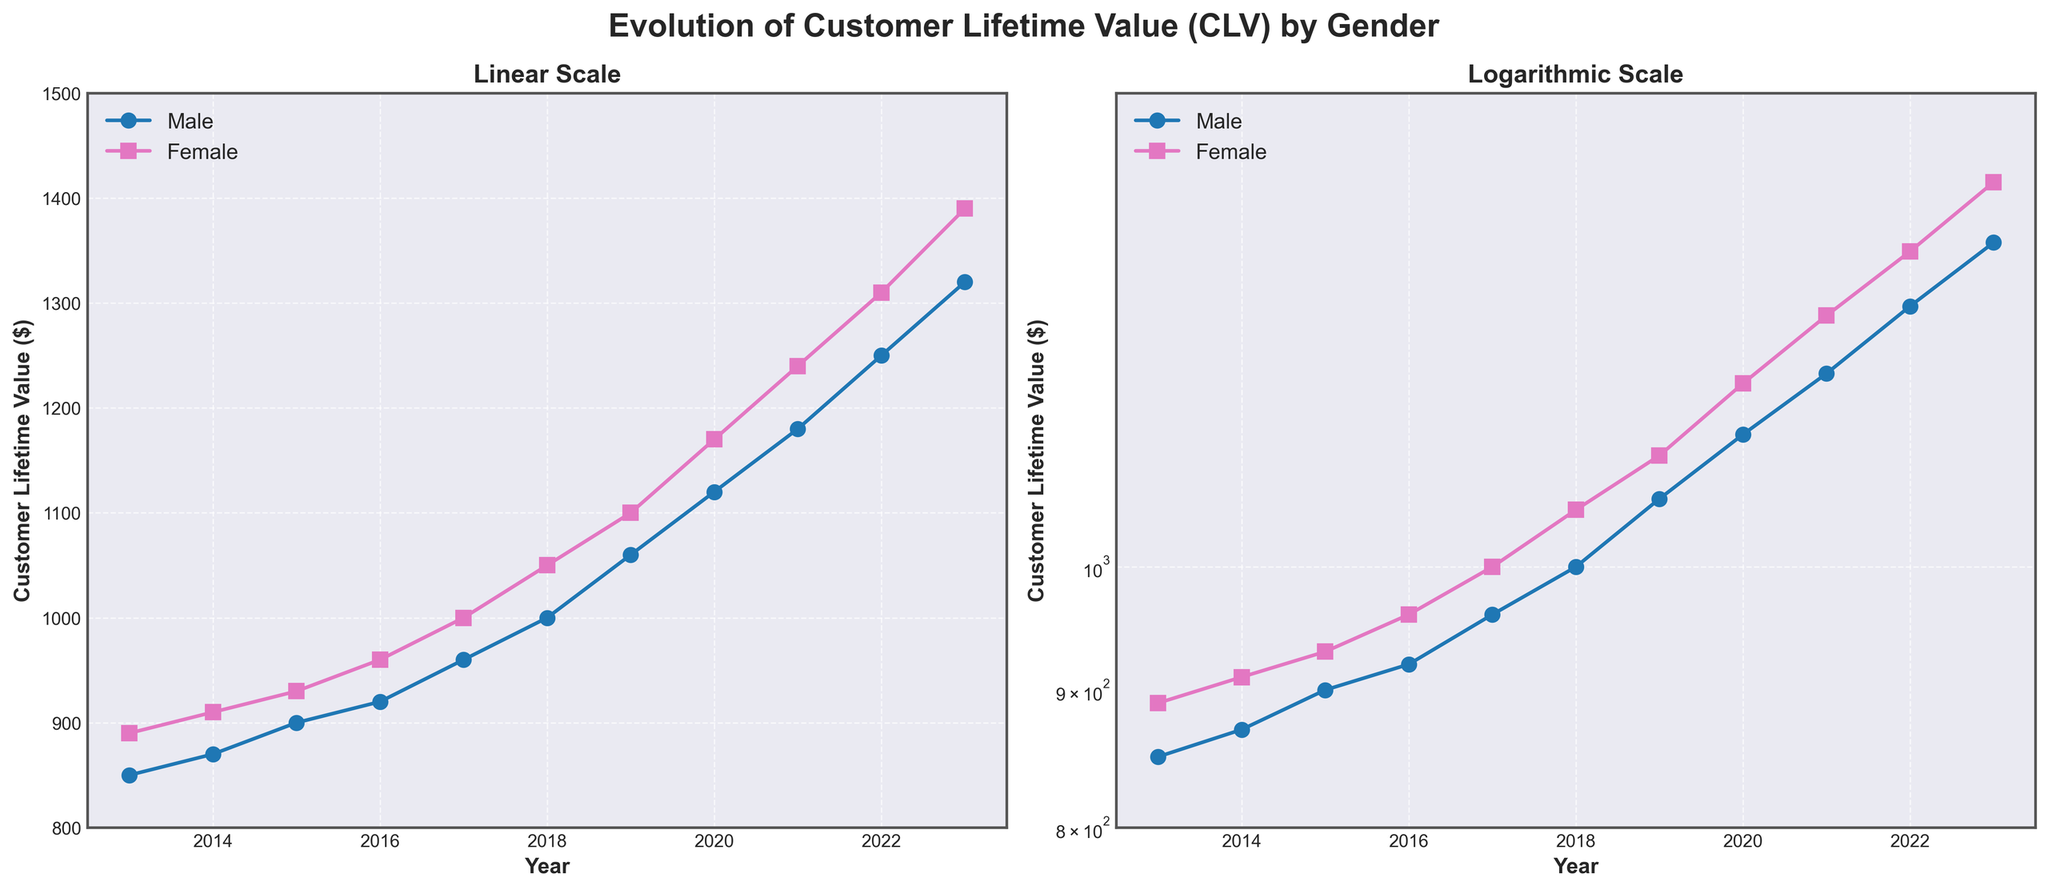what are the titles of the subplots? The titles of the subplots are written at the top of each plot. The first subplot on the left is titled "Linear Scale" and the second subplot on the right is titled "Logarithmic Scale".
Answer: Linear Scale; Logarithmic Scale How many data points are there for each gender in the subplots? To find out the number of data points, count the distinct markers for each gender in either of the plots. In the plots, there are 11 markers for Male and 11 markers for Female, indicating there are 11 data points each for Male and Female.
Answer: 11 In which year was the Customer Lifetime Value (CLV) of both genders equal? By observing the CLV lines in the linear scale subplot, the lines for male and female intersect at the year 2017. This indicates that the CLV for both genders was the same in 2017.
Answer: 2017 What is the approximate CLV for females in the year 2020? In 2020, the CLV for females can be observed by looking at the corresponding point in either plot. The y-value at 2020 for females is approximately 1170 dollars.
Answer: 1170 Which gender shows a higher overall increase in CLV over the past decade? Compare the CLV for both genders from the starting year (2013) to the final year (2023). The CLV for males increases from 850 to 1320, a difference of 470. For females, the increase is from 890 to 1390, a difference of 500. This shows that females have a higher overall increase in CLV.
Answer: Female Between which consecutive years did males show the highest increase in CLV? To find the year of highest increase, calculate the differences in CLV between consecutive years for males. The largest increase is between 2018 and 2019, where CLV increased from 1000 to 1060, a difference of 60.
Answer: 2018 to 2019 By what percentage did the CLV for females increase from 2014 to 2023? Calculate the percentage increase using the formula: 
\[
\text{Percentage Increase} = \frac{\text{CLV}_{2023} - \text{CLV}_{2014}}{\text{CLV}_{2014}} \times 100
\]
That is \[
\frac{1390 - 910}{910} \times 100 \approx 52.7\%.
\]
Answer: 52.7% What is the range of the y-axis for the logarithmic scale plot? The range of the y-axis for the logarithmic scale plot is explicitly set to be from 800 to 1500.
Answer: 800 to 1500 In which year did the gap between male and female CLV become the widest? By observing the vertical distance between the male and female lines each year on the linear scale plot, the gap appears widest in 2023. Calculating the difference, 1390 (female) - 1320 (male) = 70, confirms the widest gap in 2023.
Answer: 2023 Why might the logarithmic scale be useful in this plot? The logarithmic scale helps in visualizing multiplicative changes over time. It makes it easier to see proportional growth and compare relative rates of change over the years, especially when the range of data values is large, as with CLV values from 800 to 1500.
Answer: To visualize multiplicative changes 